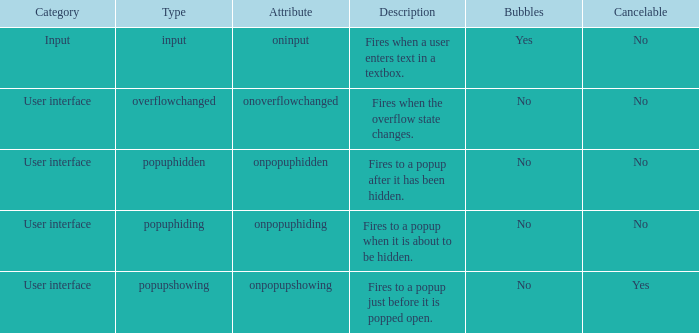Would you mind parsing the complete table? {'header': ['Category', 'Type', 'Attribute', 'Description', 'Bubbles', 'Cancelable'], 'rows': [['Input', 'input', 'oninput', 'Fires when a user enters text in a textbox.', 'Yes', 'No'], ['User interface', 'overflowchanged', 'onoverflowchanged', 'Fires when the overflow state changes.', 'No', 'No'], ['User interface', 'popuphidden', 'onpopuphidden', 'Fires to a popup after it has been hidden.', 'No', 'No'], ['User interface', 'popuphiding', 'onpopuphiding', 'Fires to a popup when it is about to be hidden.', 'No', 'No'], ['User interface', 'popupshowing', 'onpopupshowing', 'Fires to a popup just before it is popped open.', 'No', 'Yes']]} What's the category with definition being fires when the overflow status shifts. Overflowchanged. 